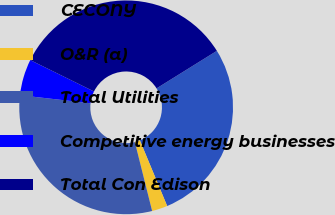<chart> <loc_0><loc_0><loc_500><loc_500><pie_chart><fcel>CECONY<fcel>O&R (a)<fcel>Total Utilities<fcel>Competitive energy businesses<fcel>Total Con Edison<nl><fcel>27.59%<fcel>2.36%<fcel>30.72%<fcel>5.48%<fcel>33.85%<nl></chart> 